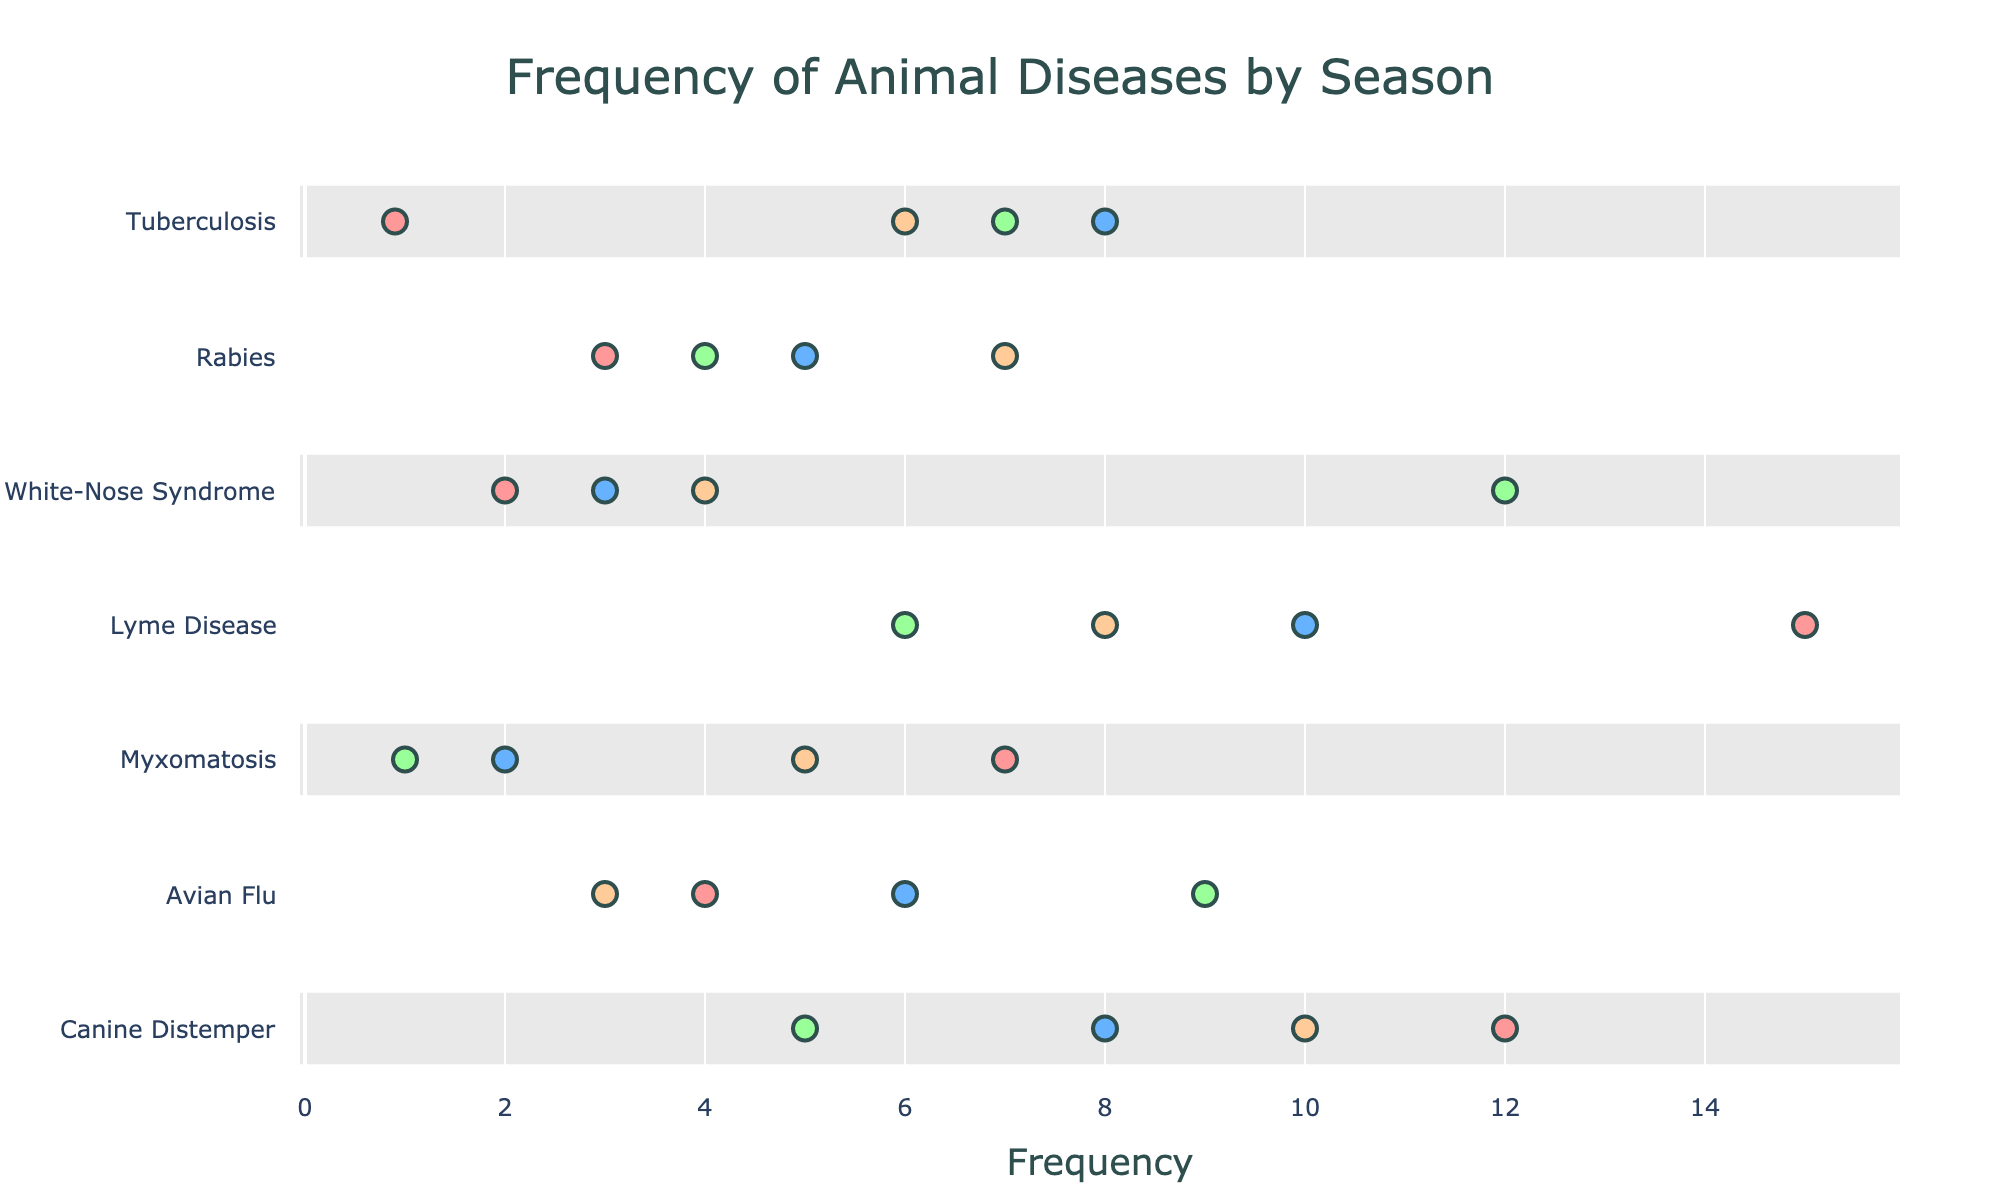What is the title of the plot? The title is usually displayed at the top center of the plot. In this case, we can see that the title of the plot is "Frequency of Animal Diseases by Season".
Answer: Frequency of Animal Diseases by Season How many diseases are displayed in the plot? The plot shows each disease with its frequency across different seasons, and there is a label for each disease. By counting these labels, we can determine the number of diseases displayed. There are seven diseases: Canine Distemper, Avian Flu, Myxomatosis, Lyme Disease, White-Nose Syndrome, Rabies, and Tuberculosis.
Answer: 7 What is the average frequency of Lyme Disease across all seasons? To find the average frequency, we need to sum the frequencies of Lyme Disease in each season and then divide by the number of seasons. The frequencies for Lyme Disease are 15 (Summer), 10 (Autumn), 6 (Winter), and 8 (Spring). The sum is 15 + 10 + 6 + 8 = 39, and there are 4 seasons, so the average is 39 / 4 = 9.75.
Answer: 9.75 Which disease has the highest frequency in Summer? By looking at the Summer column for each disease, we can identify the disease with the highest frequency. The frequencies in Summer are: Canine Distemper (12), Avian Flu (4), Myxomatosis (7), Lyme Disease (15), White-Nose Syndrome (2), Rabies (3), and Tuberculosis (0.9). The highest frequency is 15, which corresponds to Lyme Disease.
Answer: Lyme Disease During which season does Rabies have the highest frequency? We examine the frequency of Rabies in each season from the plot. The frequencies are: Summer (3), Autumn (5), Winter (4), and Spring (7). The highest frequency for Rabies is 7 in Spring.
Answer: Spring Which season has the lowest frequency of Avian Flu? We look at the frequencies of Avian Flu for each season: Summer (4), Autumn (6), Winter (9), Spring (3). The lowest frequency is 3 in Spring.
Answer: Spring What is the total frequency of Tuberculosis across all seasons? To find the total frequency, we add the frequencies of Tuberculosis in each season: Summer (0.9), Autumn (8), Winter (7), and Spring (6). The sum is 0.9 + 8 + 7 + 6 = 21.9.
Answer: 21.9 Which disease shows the highest variation in frequency across seasons? To determine the disease with the highest variation, we compare the range (difference between highest and lowest frequency) of each disease's frequency across seasons. By inspection:
- Canine Distemper: 12 - 5 = 7
- Avian Flu: 9 - 3 = 6
- Myxomatosis: 7 - 1 = 6
- Lyme Disease: 15 - 6 = 9
- White-Nose Syndrome: 12 - 2 = 10
- Rabies: 7 - 3 = 4
- Tuberculosis: 8 - 0.9 = 7.1
White-Nose Syndrome shows the highest variation of 10.
Answer: White-Nose Syndrome Compare the frequency of Canine Distemper in Winter and Tuberculosis in Winter. Which one is higher? We look at the frequencies of Canine Distemper in Winter (5) and Tuberculosis in Winter (7). Tuberculosis has a higher frequency in Winter.
Answer: Tuberculosis What is the frequency difference between Avian Flu and Rabies in Autumn? We find the frequencies for both diseases in Autumn. Avian Flu's frequency is 6, and Rabies' frequency is 5. The difference is 6 - 5 = 1.
Answer: 1 